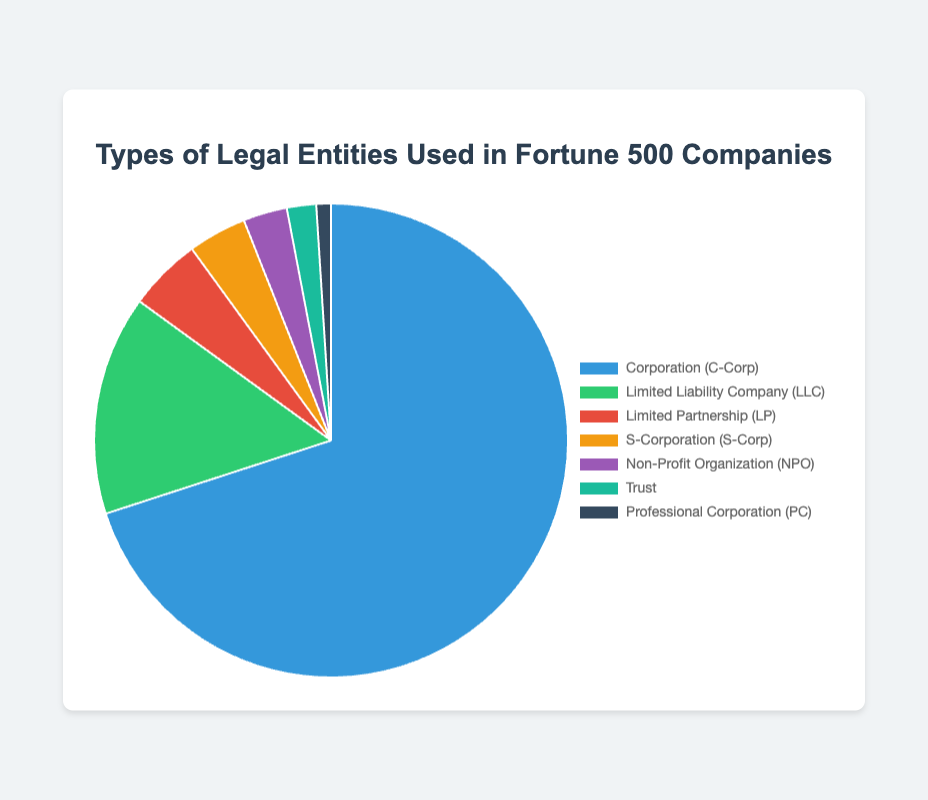Which type of legal entity is used by the majority of Fortune 500 companies? By examining the pie chart, we see that the largest segment is labeled "Corporation (C-Corp)" and accounts for 70% of the total.
Answer: Corporation (C-Corp) What is the combined percentage of Limited Liability Companies (LLC) and Limited Partnerships (LP)? The chart shows that LLCs account for 15%, and LPs account for 5%. Adding these percentages gives 15% + 5% = 20%.
Answer: 20% How much more common are Corporations (C-Corp) than Non-Profit Organizations (NPO)? By looking at the pie chart, Corporations (C-Corp) make up 70%, while NPOs account for 3%. The difference is 70% - 3% = 67%.
Answer: 67% Which entity type is the least represented among Fortune 500 companies, and what is its percentage? The smallest segment of the pie chart is labeled "Professional Corporation (PC)" with a percentage of 1%.
Answer: Professional Corporation (PC), 1% Compare the combined percentage of S-Corporations (S-Corp) and Trusts to the percentage of Limited Liability Companies (LLC). Which is higher? S-Corporations (S-Corp) account for 4%, and Trusts make up 2%, giving a combined total of 4% + 2% = 6%. LLCs alone account for 15%, which is higher than 6%.
Answer: LLC's 15% is higher What percentage of Fortune 500 companies are either Non-Profit Organizations (NPO) or Professional Corporations (PC)? The pie chart shows that NPOs account for 3%, and PCs represent 1%. Adding these percentages gives 3% + 1% = 4%.
Answer: 4% If we were to group Limited Partnerships (LP) and S-Corporations (S-Corp) together, what would their combined percentage be compared to the percentage of Corporations (C-Corp)? LPs are 5%, and S-Corps are 4%, together making 5% + 4% = 9%. Corporations (C-Corp) alone are 70%, which is significantly higher than 9%.
Answer: Corporations (C-Corp) What color represents Limited Liability Companies (LLC) on the pie chart? The segment for Limited Liability Companies (LLC) is shown in green.
Answer: Green 